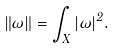<formula> <loc_0><loc_0><loc_500><loc_500>\| \omega \| = \int _ { X } | \omega | ^ { 2 } .</formula> 